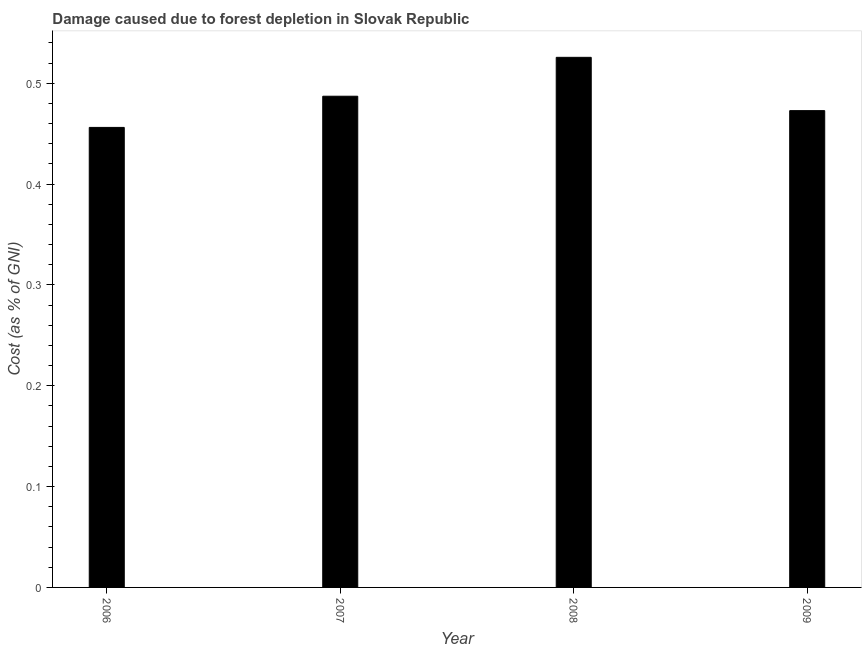Does the graph contain any zero values?
Offer a very short reply. No. Does the graph contain grids?
Your response must be concise. No. What is the title of the graph?
Provide a short and direct response. Damage caused due to forest depletion in Slovak Republic. What is the label or title of the Y-axis?
Ensure brevity in your answer.  Cost (as % of GNI). What is the damage caused due to forest depletion in 2008?
Provide a short and direct response. 0.53. Across all years, what is the maximum damage caused due to forest depletion?
Your answer should be compact. 0.53. Across all years, what is the minimum damage caused due to forest depletion?
Provide a succinct answer. 0.46. In which year was the damage caused due to forest depletion maximum?
Give a very brief answer. 2008. What is the sum of the damage caused due to forest depletion?
Offer a very short reply. 1.94. What is the difference between the damage caused due to forest depletion in 2007 and 2009?
Offer a very short reply. 0.01. What is the average damage caused due to forest depletion per year?
Provide a succinct answer. 0.49. What is the median damage caused due to forest depletion?
Your answer should be very brief. 0.48. In how many years, is the damage caused due to forest depletion greater than 0.44 %?
Your response must be concise. 4. Do a majority of the years between 2009 and 2006 (inclusive) have damage caused due to forest depletion greater than 0.44 %?
Make the answer very short. Yes. What is the ratio of the damage caused due to forest depletion in 2006 to that in 2007?
Your response must be concise. 0.94. Is the damage caused due to forest depletion in 2007 less than that in 2008?
Make the answer very short. Yes. What is the difference between the highest and the second highest damage caused due to forest depletion?
Your answer should be compact. 0.04. Is the sum of the damage caused due to forest depletion in 2007 and 2008 greater than the maximum damage caused due to forest depletion across all years?
Offer a very short reply. Yes. What is the difference between the highest and the lowest damage caused due to forest depletion?
Make the answer very short. 0.07. In how many years, is the damage caused due to forest depletion greater than the average damage caused due to forest depletion taken over all years?
Keep it short and to the point. 2. How many bars are there?
Your answer should be compact. 4. Are all the bars in the graph horizontal?
Offer a terse response. No. How many years are there in the graph?
Make the answer very short. 4. What is the difference between two consecutive major ticks on the Y-axis?
Keep it short and to the point. 0.1. Are the values on the major ticks of Y-axis written in scientific E-notation?
Give a very brief answer. No. What is the Cost (as % of GNI) in 2006?
Keep it short and to the point. 0.46. What is the Cost (as % of GNI) of 2007?
Keep it short and to the point. 0.49. What is the Cost (as % of GNI) of 2008?
Make the answer very short. 0.53. What is the Cost (as % of GNI) in 2009?
Your answer should be compact. 0.47. What is the difference between the Cost (as % of GNI) in 2006 and 2007?
Your answer should be very brief. -0.03. What is the difference between the Cost (as % of GNI) in 2006 and 2008?
Your answer should be compact. -0.07. What is the difference between the Cost (as % of GNI) in 2006 and 2009?
Provide a succinct answer. -0.02. What is the difference between the Cost (as % of GNI) in 2007 and 2008?
Keep it short and to the point. -0.04. What is the difference between the Cost (as % of GNI) in 2007 and 2009?
Your answer should be very brief. 0.01. What is the difference between the Cost (as % of GNI) in 2008 and 2009?
Make the answer very short. 0.05. What is the ratio of the Cost (as % of GNI) in 2006 to that in 2007?
Provide a succinct answer. 0.94. What is the ratio of the Cost (as % of GNI) in 2006 to that in 2008?
Ensure brevity in your answer.  0.87. What is the ratio of the Cost (as % of GNI) in 2006 to that in 2009?
Your response must be concise. 0.96. What is the ratio of the Cost (as % of GNI) in 2007 to that in 2008?
Ensure brevity in your answer.  0.93. What is the ratio of the Cost (as % of GNI) in 2008 to that in 2009?
Keep it short and to the point. 1.11. 